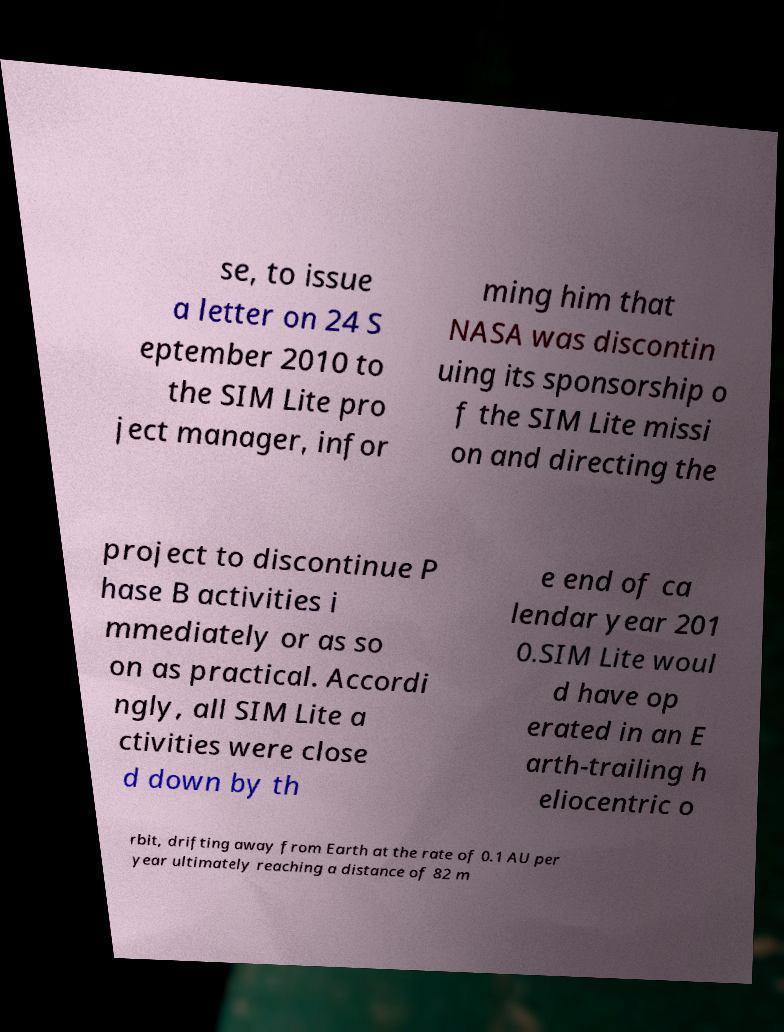Can you read and provide the text displayed in the image?This photo seems to have some interesting text. Can you extract and type it out for me? se, to issue a letter on 24 S eptember 2010 to the SIM Lite pro ject manager, infor ming him that NASA was discontin uing its sponsorship o f the SIM Lite missi on and directing the project to discontinue P hase B activities i mmediately or as so on as practical. Accordi ngly, all SIM Lite a ctivities were close d down by th e end of ca lendar year 201 0.SIM Lite woul d have op erated in an E arth-trailing h eliocentric o rbit, drifting away from Earth at the rate of 0.1 AU per year ultimately reaching a distance of 82 m 